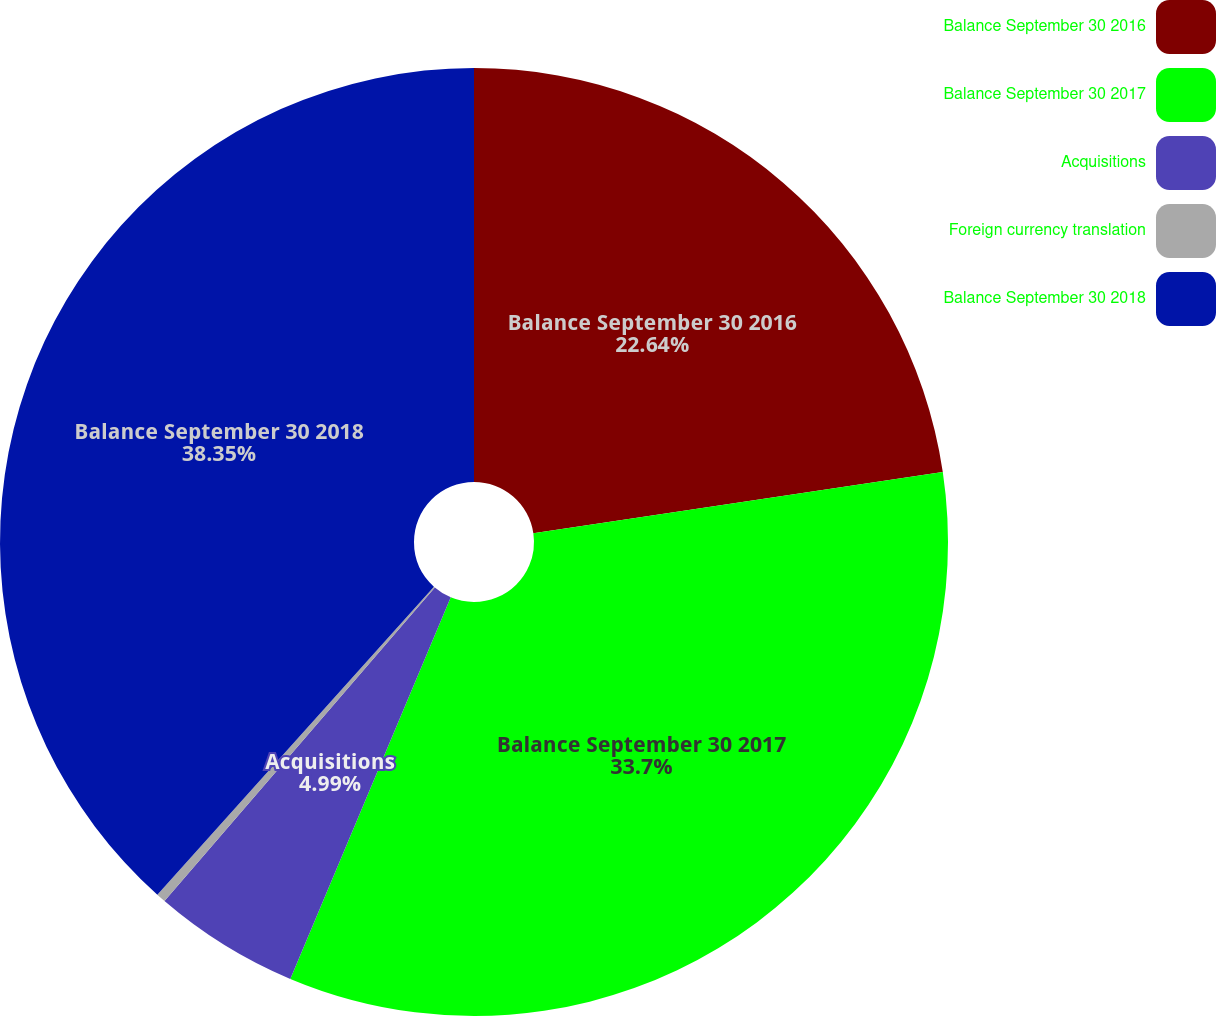<chart> <loc_0><loc_0><loc_500><loc_500><pie_chart><fcel>Balance September 30 2016<fcel>Balance September 30 2017<fcel>Acquisitions<fcel>Foreign currency translation<fcel>Balance September 30 2018<nl><fcel>22.64%<fcel>33.7%<fcel>4.99%<fcel>0.32%<fcel>38.36%<nl></chart> 